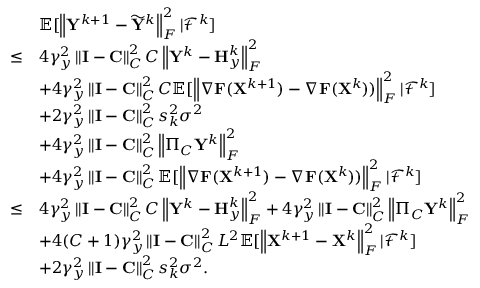Convert formula to latex. <formula><loc_0><loc_0><loc_500><loc_500>\begin{array} { r l } & { { \mathbb { E } } [ \left \| { Y } ^ { k + 1 } - \widetilde { Y } ^ { k } \right \| _ { F } ^ { 2 } | { \mathcal { F } } ^ { k } ] } \\ { \leq } & { 4 \gamma _ { y } ^ { 2 } \left \| { I } - { C } \right \| _ { C } ^ { 2 } C \left \| { Y } ^ { k } - { H } _ { y } ^ { k } \right \| _ { F } ^ { 2 } } \\ & { + 4 \gamma _ { y } ^ { 2 } \left \| { I } - { C } \right \| _ { C } ^ { 2 } C { \mathbb { E } } [ \left \| \nabla { F } ( { X } ^ { k + 1 } ) - \nabla { F } ( { X } ^ { k } ) ) \right \| _ { F } ^ { 2 } | { \mathcal { F } } ^ { k } ] } \\ & { + 2 \gamma _ { y } ^ { 2 } \left \| { I } - { C } \right \| _ { C } ^ { 2 } s _ { k } ^ { 2 } \sigma ^ { 2 } } \\ & { + 4 \gamma _ { y } ^ { 2 } \left \| { I } - { C } \right \| _ { C } ^ { 2 } \left \| \Pi _ { C } { Y } ^ { k } \right \| _ { F } ^ { 2 } } \\ & { + 4 \gamma _ { y } ^ { 2 } \left \| { I } - { C } \right \| _ { C } ^ { 2 } { \mathbb { E } } [ \left \| \nabla { F } ( { X } ^ { k + 1 } ) - \nabla { F } ( { X } ^ { k } ) ) \right \| _ { F } ^ { 2 } | { \mathcal { F } } ^ { k } ] } \\ { \leq } & { 4 \gamma _ { y } ^ { 2 } \left \| { I } - { C } \right \| _ { C } ^ { 2 } C \left \| { Y } ^ { k } - { H } _ { y } ^ { k } \right \| _ { F } ^ { 2 } + 4 \gamma _ { y } ^ { 2 } \left \| { I } - { C } \right \| _ { C } ^ { 2 } \left \| \Pi _ { C } { Y } ^ { k } \right \| _ { F } ^ { 2 } } \\ & { + 4 ( C + 1 ) \gamma _ { y } ^ { 2 } \left \| { I } - { C } \right \| _ { C } ^ { 2 } L ^ { 2 } { \mathbb { E } } [ \left \| { X } ^ { k + 1 } - { X } ^ { k } \right \| _ { F } ^ { 2 } | { \mathcal { F } } ^ { k } ] } \\ & { + 2 \gamma _ { y } ^ { 2 } \left \| { I } - { C } \right \| _ { C } ^ { 2 } s _ { k } ^ { 2 } \sigma ^ { 2 } . } \end{array}</formula> 